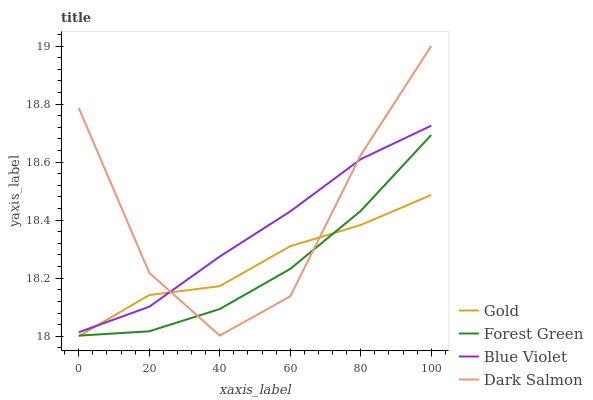Does Forest Green have the minimum area under the curve?
Answer yes or no. Yes. Does Dark Salmon have the maximum area under the curve?
Answer yes or no. Yes. Does Blue Violet have the minimum area under the curve?
Answer yes or no. No. Does Blue Violet have the maximum area under the curve?
Answer yes or no. No. Is Blue Violet the smoothest?
Answer yes or no. Yes. Is Dark Salmon the roughest?
Answer yes or no. Yes. Is Gold the smoothest?
Answer yes or no. No. Is Gold the roughest?
Answer yes or no. No. Does Gold have the lowest value?
Answer yes or no. Yes. Does Blue Violet have the lowest value?
Answer yes or no. No. Does Dark Salmon have the highest value?
Answer yes or no. Yes. Does Blue Violet have the highest value?
Answer yes or no. No. Is Forest Green less than Blue Violet?
Answer yes or no. Yes. Is Blue Violet greater than Forest Green?
Answer yes or no. Yes. Does Dark Salmon intersect Gold?
Answer yes or no. Yes. Is Dark Salmon less than Gold?
Answer yes or no. No. Is Dark Salmon greater than Gold?
Answer yes or no. No. Does Forest Green intersect Blue Violet?
Answer yes or no. No. 